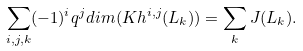<formula> <loc_0><loc_0><loc_500><loc_500>\sum _ { i , j , k } ( - 1 ) ^ { i } q ^ { j } d i m ( K h ^ { i , j } ( L _ { k } ) ) = \sum _ { k } J ( L _ { k } ) .</formula> 